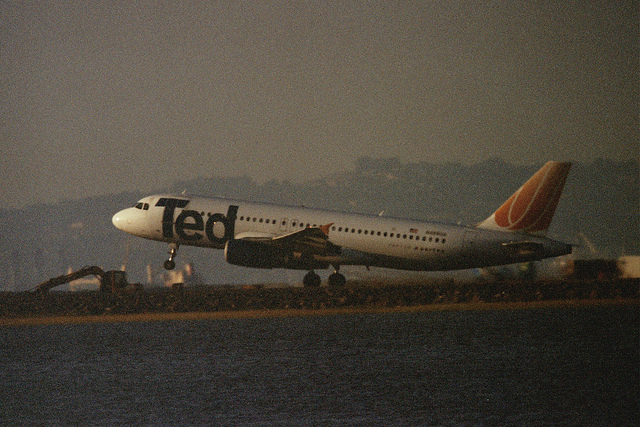<image>On the tail of the plane, what are the three letters written? I am not sure what the three letters on the tail of the plane are. It could be 'ted' or there could be no letters. On the tail of the plane, what are the three letters written? There are three letters written on the tail of the plane and those are 'ted'. 